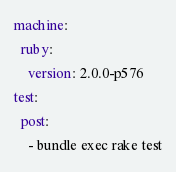Convert code to text. <code><loc_0><loc_0><loc_500><loc_500><_YAML_>machine:
  ruby:
    version: 2.0.0-p576
test:
  post:
    - bundle exec rake test</code> 